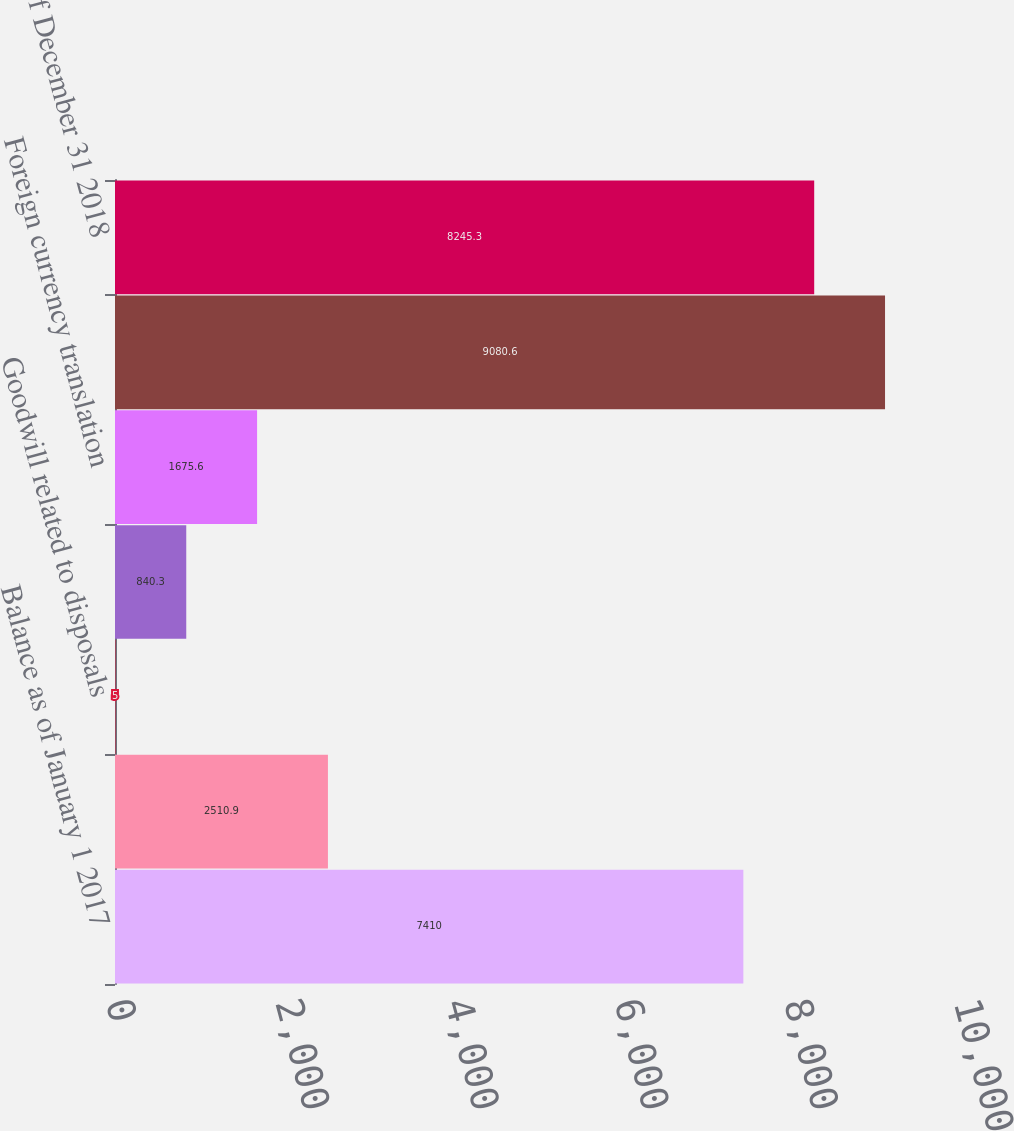Convert chart. <chart><loc_0><loc_0><loc_500><loc_500><bar_chart><fcel>Balance as of January 1 2017<fcel>Goodwill related to current<fcel>Goodwill related to disposals<fcel>Goodwill related to prior year<fcel>Foreign currency translation<fcel>Balance as of December 31 2017<fcel>Balance as of December 31 2018<nl><fcel>7410<fcel>2510.9<fcel>5<fcel>840.3<fcel>1675.6<fcel>9080.6<fcel>8245.3<nl></chart> 